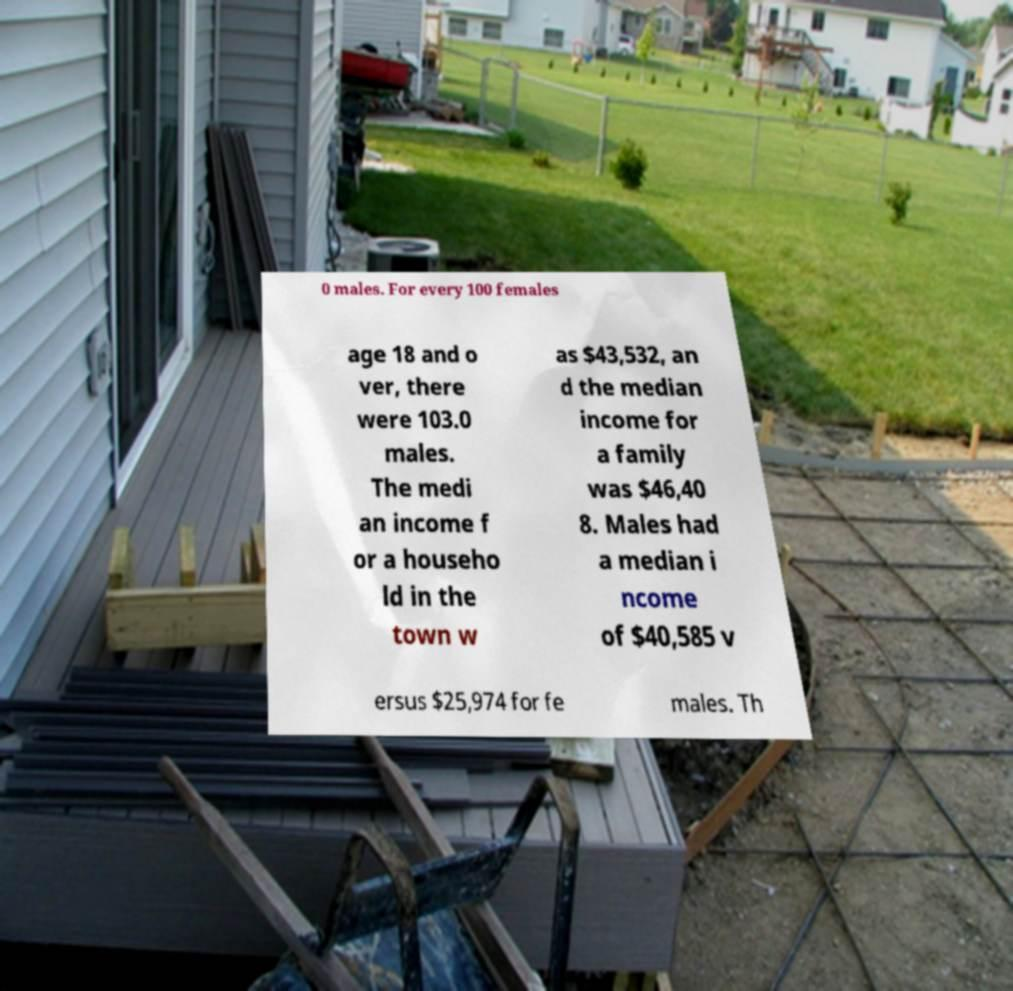Please identify and transcribe the text found in this image. 0 males. For every 100 females age 18 and o ver, there were 103.0 males. The medi an income f or a househo ld in the town w as $43,532, an d the median income for a family was $46,40 8. Males had a median i ncome of $40,585 v ersus $25,974 for fe males. Th 